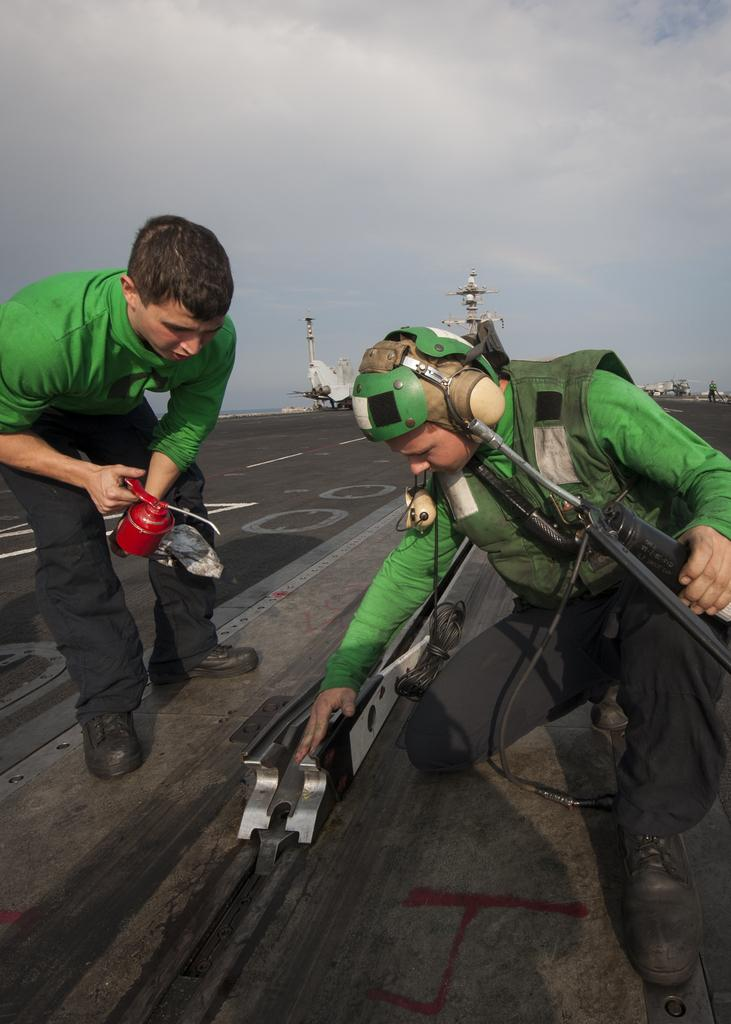How many men are in the image? There are two men in the image. What are the positions of the men in the image? One man is bending, and the other man is squatting. Where are the men located in the image? They are both on a pavement. What are the men holding in their hands? They are holding objects in their hands. What can be seen in the background of the image? The sky is visible in the background of the image. Is there a lake visible in the image? No, there is no lake present in the image; only a pavement and the sky are visible. 